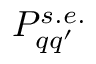Convert formula to latex. <formula><loc_0><loc_0><loc_500><loc_500>P _ { q q ^ { \prime } } ^ { s . e . }</formula> 